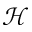Convert formula to latex. <formula><loc_0><loc_0><loc_500><loc_500>\mathcal { H }</formula> 